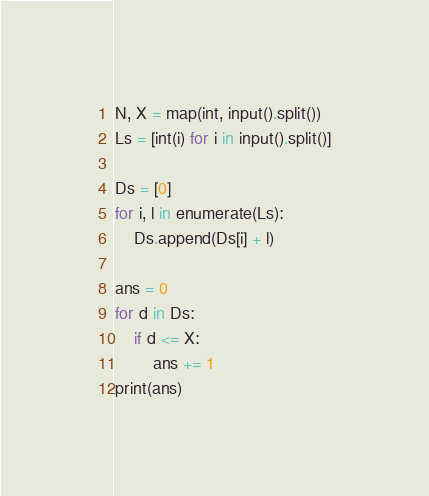Convert code to text. <code><loc_0><loc_0><loc_500><loc_500><_Python_>N, X = map(int, input().split())
Ls = [int(i) for i in input().split()]

Ds = [0]
for i, l in enumerate(Ls):
    Ds.append(Ds[i] + l)

ans = 0
for d in Ds:
    if d <= X:
        ans += 1
print(ans)
</code> 